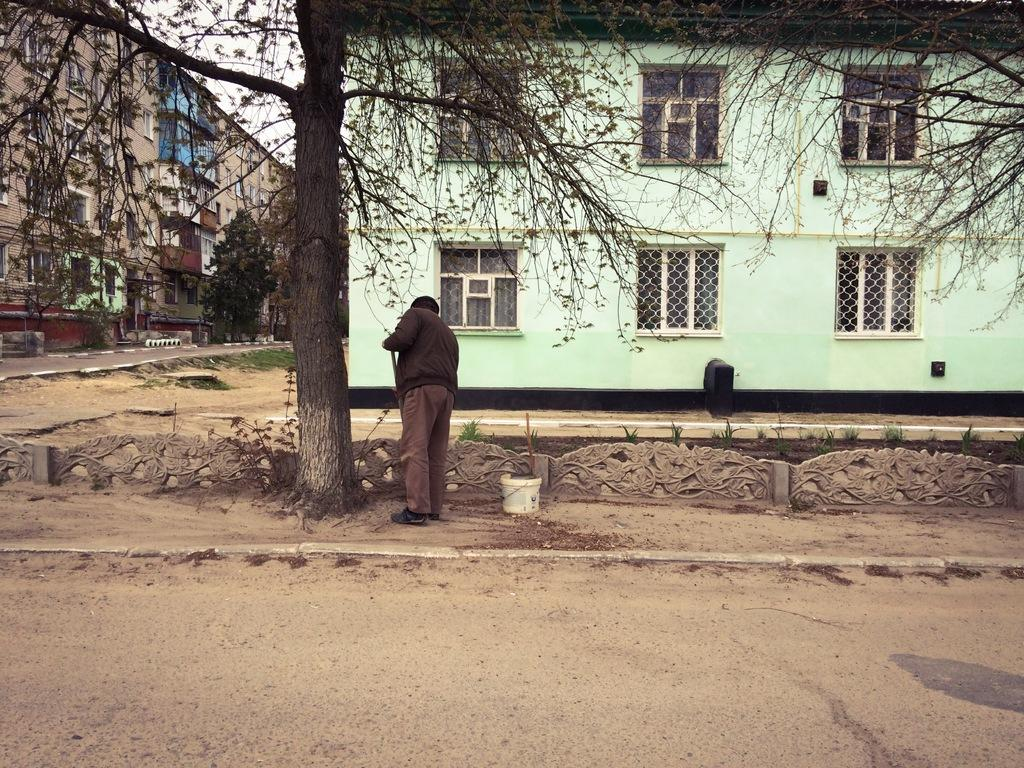What is the main subject of the image? There is a person standing in the image. What type of terrain is visible in the image? There is sand, a path, and grass visible in the image. What other natural elements can be seen in the image? There are plants, trees, and the sky visible in the image. What man-made structures are present in the image? There are buildings and a road visible in the image. What type of berry can be seen growing on the person in the image? There are no berries visible on the person in the image. How does the person in the image feel about the hot weather? The image does not provide any information about the person's feelings or the weather conditions. 